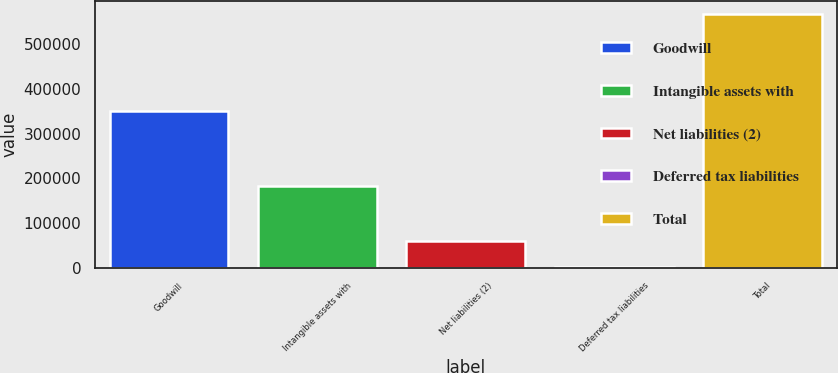<chart> <loc_0><loc_0><loc_500><loc_500><bar_chart><fcel>Goodwill<fcel>Intangible assets with<fcel>Net liabilities (2)<fcel>Deferred tax liabilities<fcel>Total<nl><fcel>350093<fcel>182252<fcel>59398.2<fcel>2908<fcel>567810<nl></chart> 